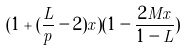Convert formula to latex. <formula><loc_0><loc_0><loc_500><loc_500>( 1 + ( \frac { L } { p } - 2 ) x ) ( 1 - \frac { 2 M x } { 1 - L } )</formula> 